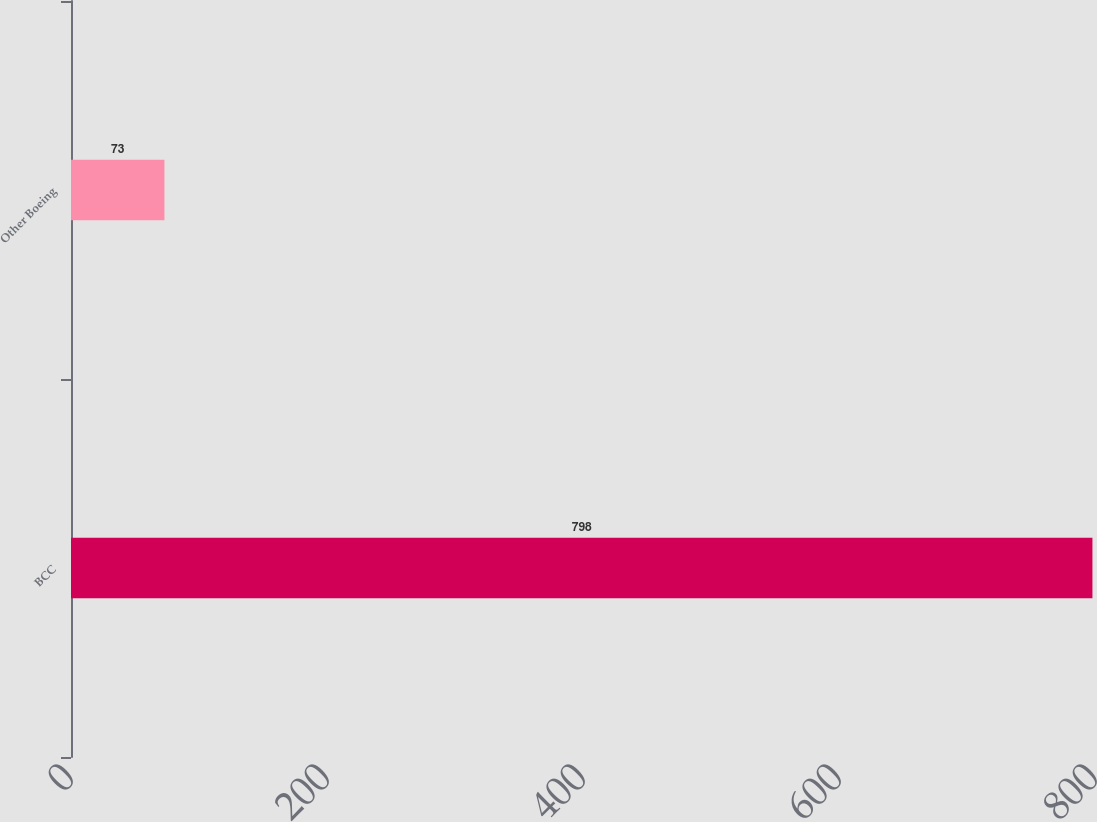Convert chart. <chart><loc_0><loc_0><loc_500><loc_500><bar_chart><fcel>BCC<fcel>Other Boeing<nl><fcel>798<fcel>73<nl></chart> 